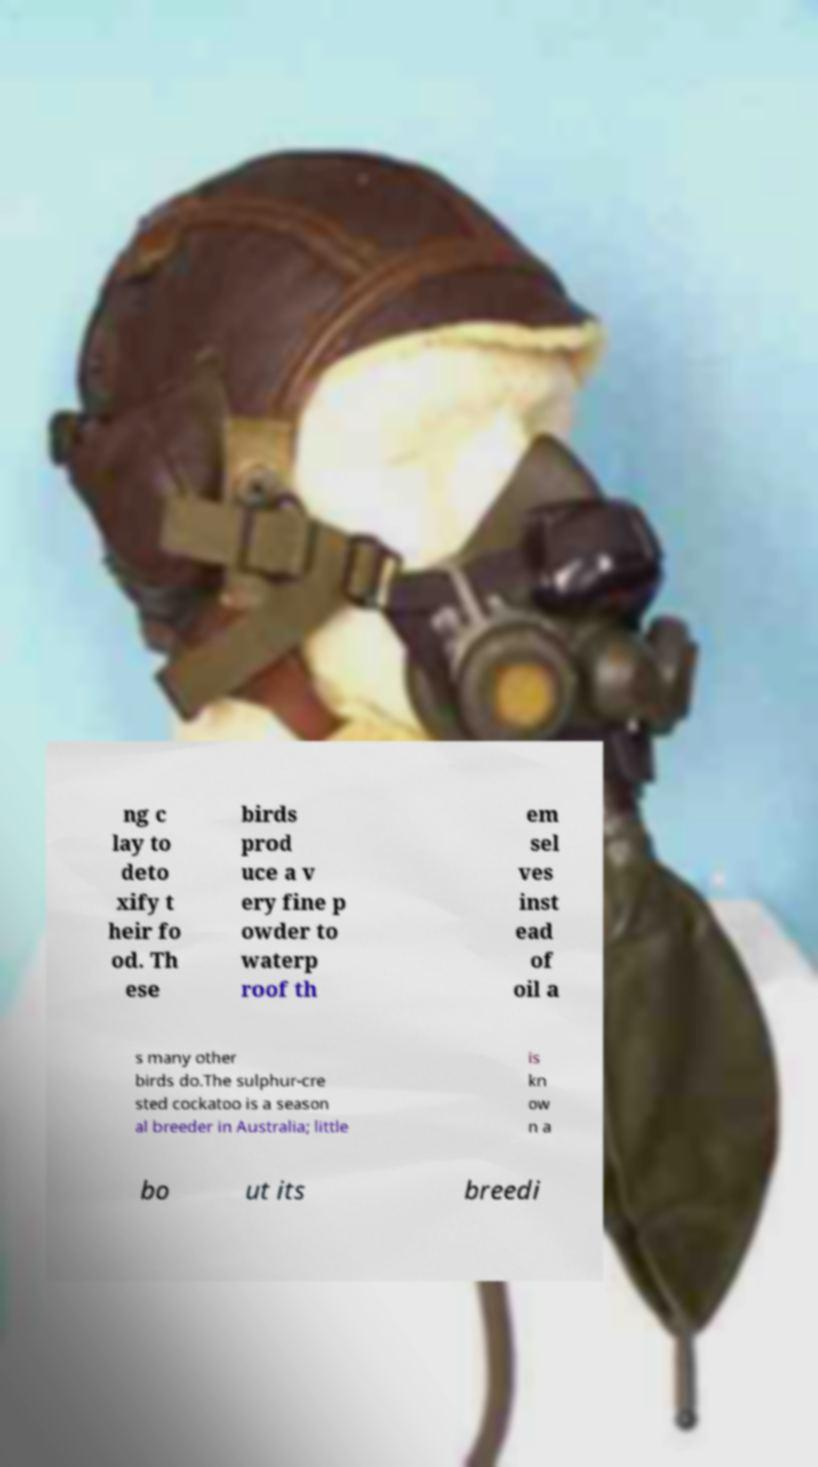Please identify and transcribe the text found in this image. ng c lay to deto xify t heir fo od. Th ese birds prod uce a v ery fine p owder to waterp roof th em sel ves inst ead of oil a s many other birds do.The sulphur-cre sted cockatoo is a season al breeder in Australia; little is kn ow n a bo ut its breedi 